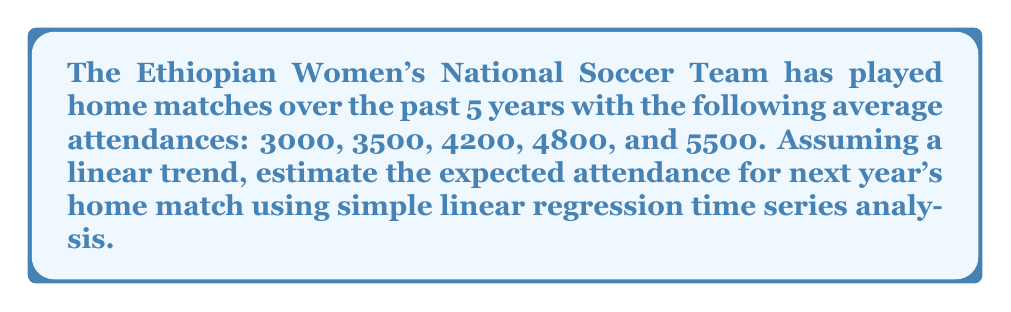Provide a solution to this math problem. To estimate the expected attendance for next year using simple linear regression time series analysis, we'll follow these steps:

1. Assign time values (t) to each year:
   Year 1: t = 0, Attendance = 3000
   Year 2: t = 1, Attendance = 3500
   Year 3: t = 2, Attendance = 4200
   Year 4: t = 3, Attendance = 4800
   Year 5: t = 4, Attendance = 5500

2. Calculate the means of t and attendance (y):
   $\bar{t} = \frac{0 + 1 + 2 + 3 + 4}{5} = 2$
   $\bar{y} = \frac{3000 + 3500 + 4200 + 4800 + 5500}{5} = 4200$

3. Calculate the slope (b) of the regression line:
   $$b = \frac{\sum(t - \bar{t})(y - \bar{y})}{\sum(t - \bar{t})^2}$$

   $\sum(t - \bar{t})(y - \bar{y}) = (-2)(-1200) + (-1)(-700) + (0)(0) + (1)(600) + (2)(1300) = 4100$
   $\sum(t - \bar{t})^2 = (-2)^2 + (-1)^2 + 0^2 + 1^2 + 2^2 = 10$

   $$b = \frac{4100}{10} = 410$$

4. Calculate the y-intercept (a):
   $$a = \bar{y} - b\bar{t} = 4200 - 410(2) = 3380$$

5. The regression line equation is:
   $$y = a + bt = 3380 + 410t$$

6. To estimate the attendance for next year (Year 6, t = 5):
   $$y = 3380 + 410(5) = 5430$$

Therefore, the expected attendance for next year's home match is 5430.
Answer: 5430 spectators 